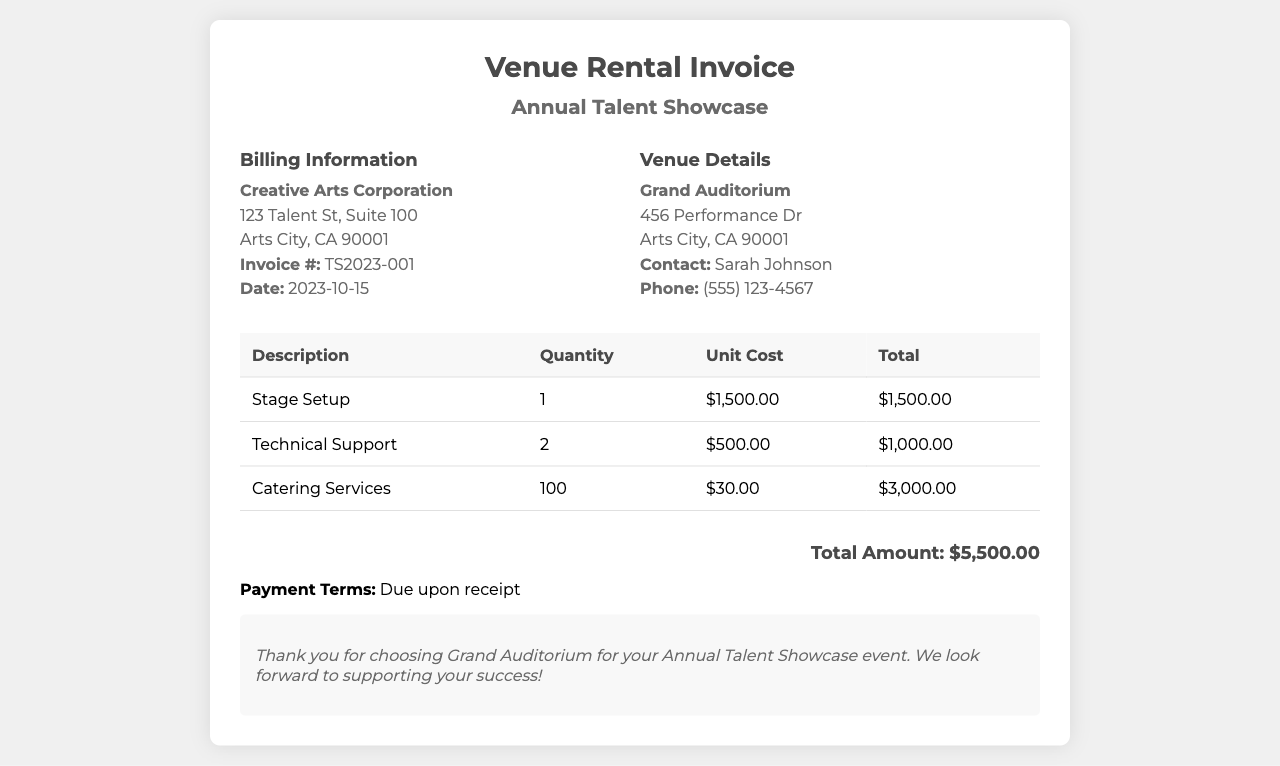what is the invoice number? The invoice number is mentioned in the billing information section of the document as TS2023-001.
Answer: TS2023-001 who is the venue contact person? The venue contact person is listed under the venue details section as Sarah Johnson.
Answer: Sarah Johnson what is the total amount due? The total amount due is presented in the summary as $5,500.00.
Answer: $5,500.00 how many technical support staff were included? The quantity of technical support staff is provided in the table as 2.
Answer: 2 what is the unit cost of catering services? The unit cost for catering services can be found in the table, which lists it as $30.00.
Answer: $30.00 what is the address of Creative Arts Corporation? The address of Creative Arts Corporation is detailed in the billing information as 123 Talent St, Suite 100, Arts City, CA 90001.
Answer: 123 Talent St, Suite 100 how much was charged for stage setup? The charge for stage setup is shown in the table as $1,500.00.
Answer: $1,500.00 when is the payment due? The payment terms state that payment is due upon receipt.
Answer: Upon receipt what type of event is this invoice for? The invoice is specifically for the Annual Talent Showcase event, as mentioned in the header.
Answer: Annual Talent Showcase 